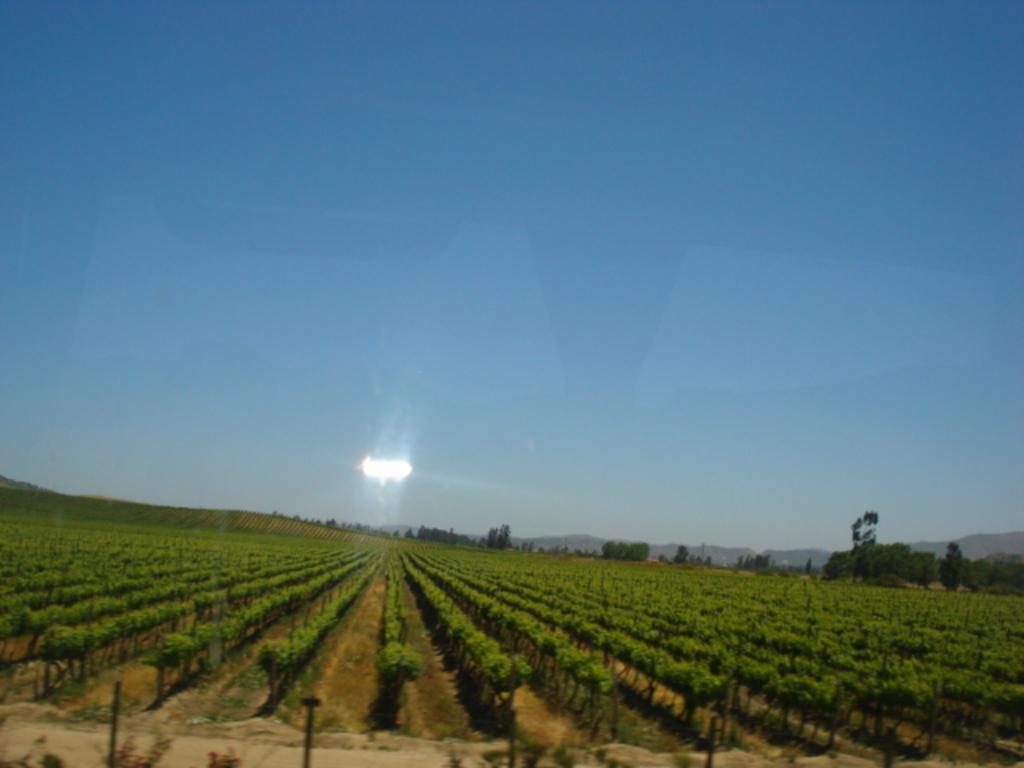In one or two sentences, can you explain what this image depicts? This is a view of agricultural land. In this image we can see there are trees. In the background there is a sky. 